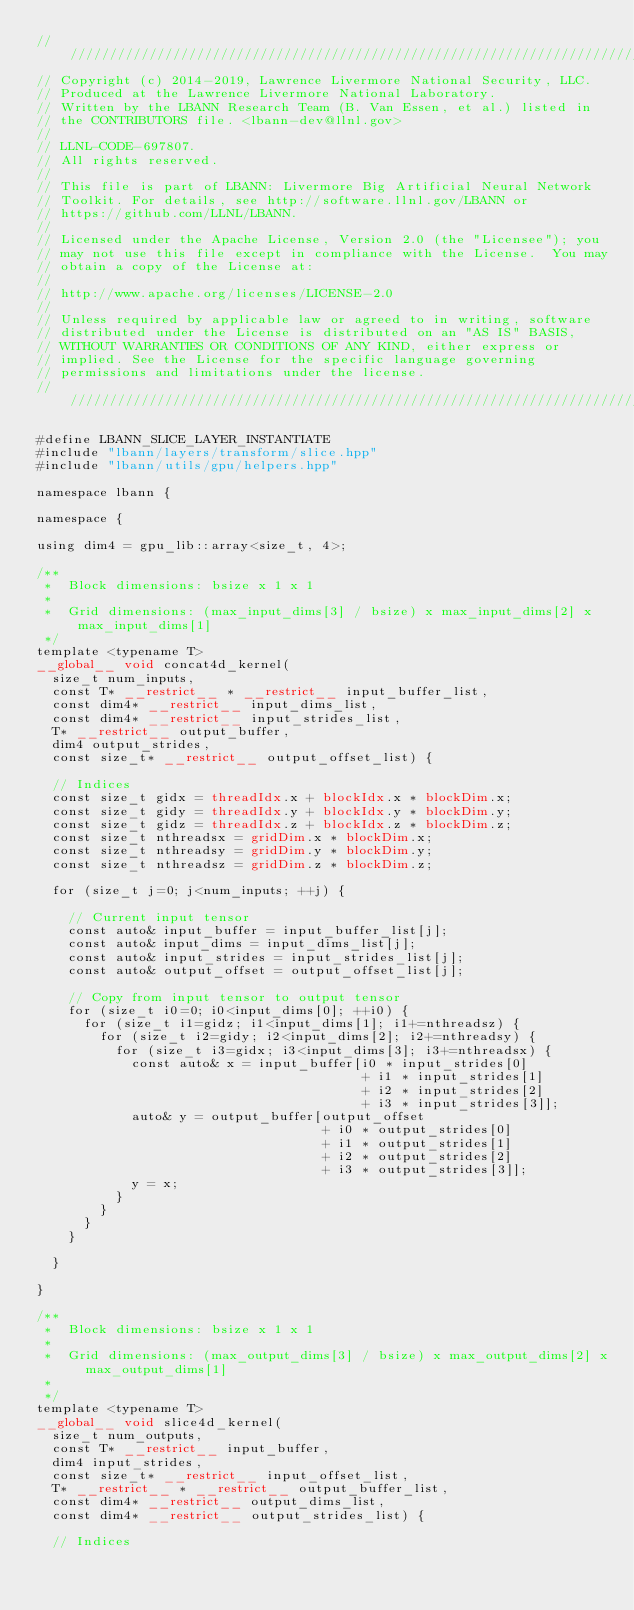<code> <loc_0><loc_0><loc_500><loc_500><_Cuda_>////////////////////////////////////////////////////////////////////////////////
// Copyright (c) 2014-2019, Lawrence Livermore National Security, LLC.
// Produced at the Lawrence Livermore National Laboratory.
// Written by the LBANN Research Team (B. Van Essen, et al.) listed in
// the CONTRIBUTORS file. <lbann-dev@llnl.gov>
//
// LLNL-CODE-697807.
// All rights reserved.
//
// This file is part of LBANN: Livermore Big Artificial Neural Network
// Toolkit. For details, see http://software.llnl.gov/LBANN or
// https://github.com/LLNL/LBANN.
//
// Licensed under the Apache License, Version 2.0 (the "Licensee"); you
// may not use this file except in compliance with the License.  You may
// obtain a copy of the License at:
//
// http://www.apache.org/licenses/LICENSE-2.0
//
// Unless required by applicable law or agreed to in writing, software
// distributed under the License is distributed on an "AS IS" BASIS,
// WITHOUT WARRANTIES OR CONDITIONS OF ANY KIND, either express or
// implied. See the License for the specific language governing
// permissions and limitations under the license.
////////////////////////////////////////////////////////////////////////////////

#define LBANN_SLICE_LAYER_INSTANTIATE
#include "lbann/layers/transform/slice.hpp"
#include "lbann/utils/gpu/helpers.hpp"

namespace lbann {

namespace {

using dim4 = gpu_lib::array<size_t, 4>;

/**
 *  Block dimensions: bsize x 1 x 1
 *
 *  Grid dimensions: (max_input_dims[3] / bsize) x max_input_dims[2] x max_input_dims[1]
 */
template <typename T>
__global__ void concat4d_kernel(
  size_t num_inputs,
  const T* __restrict__ * __restrict__ input_buffer_list,
  const dim4* __restrict__ input_dims_list,
  const dim4* __restrict__ input_strides_list,
  T* __restrict__ output_buffer,
  dim4 output_strides,
  const size_t* __restrict__ output_offset_list) {

  // Indices
  const size_t gidx = threadIdx.x + blockIdx.x * blockDim.x;
  const size_t gidy = threadIdx.y + blockIdx.y * blockDim.y;
  const size_t gidz = threadIdx.z + blockIdx.z * blockDim.z;
  const size_t nthreadsx = gridDim.x * blockDim.x;
  const size_t nthreadsy = gridDim.y * blockDim.y;
  const size_t nthreadsz = gridDim.z * blockDim.z;

  for (size_t j=0; j<num_inputs; ++j) {

    // Current input tensor
    const auto& input_buffer = input_buffer_list[j];
    const auto& input_dims = input_dims_list[j];
    const auto& input_strides = input_strides_list[j];
    const auto& output_offset = output_offset_list[j];

    // Copy from input tensor to output tensor
    for (size_t i0=0; i0<input_dims[0]; ++i0) {
      for (size_t i1=gidz; i1<input_dims[1]; i1+=nthreadsz) {
        for (size_t i2=gidy; i2<input_dims[2]; i2+=nthreadsy) {
          for (size_t i3=gidx; i3<input_dims[3]; i3+=nthreadsx) {
            const auto& x = input_buffer[i0 * input_strides[0]
                                         + i1 * input_strides[1]
                                         + i2 * input_strides[2]
                                         + i3 * input_strides[3]];
            auto& y = output_buffer[output_offset
                                    + i0 * output_strides[0]
                                    + i1 * output_strides[1]
                                    + i2 * output_strides[2]
                                    + i3 * output_strides[3]];
            y = x;
          }
        }
      }
    }

  }

}

/**
 *  Block dimensions: bsize x 1 x 1
 *
 *  Grid dimensions: (max_output_dims[3] / bsize) x max_output_dims[2] x max_output_dims[1]
 *
 */
template <typename T>
__global__ void slice4d_kernel(
  size_t num_outputs,
  const T* __restrict__ input_buffer,
  dim4 input_strides,
  const size_t* __restrict__ input_offset_list,
  T* __restrict__ * __restrict__ output_buffer_list,
  const dim4* __restrict__ output_dims_list,
  const dim4* __restrict__ output_strides_list) {

  // Indices</code> 